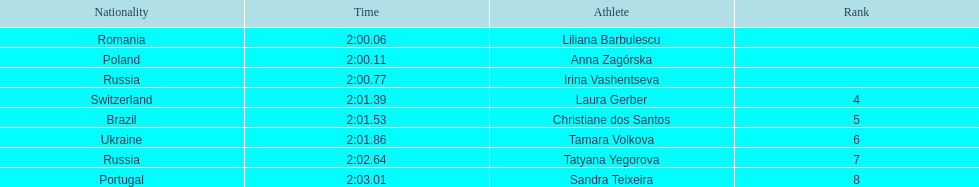What is the number of russian participants in this set of semifinals? 2. 